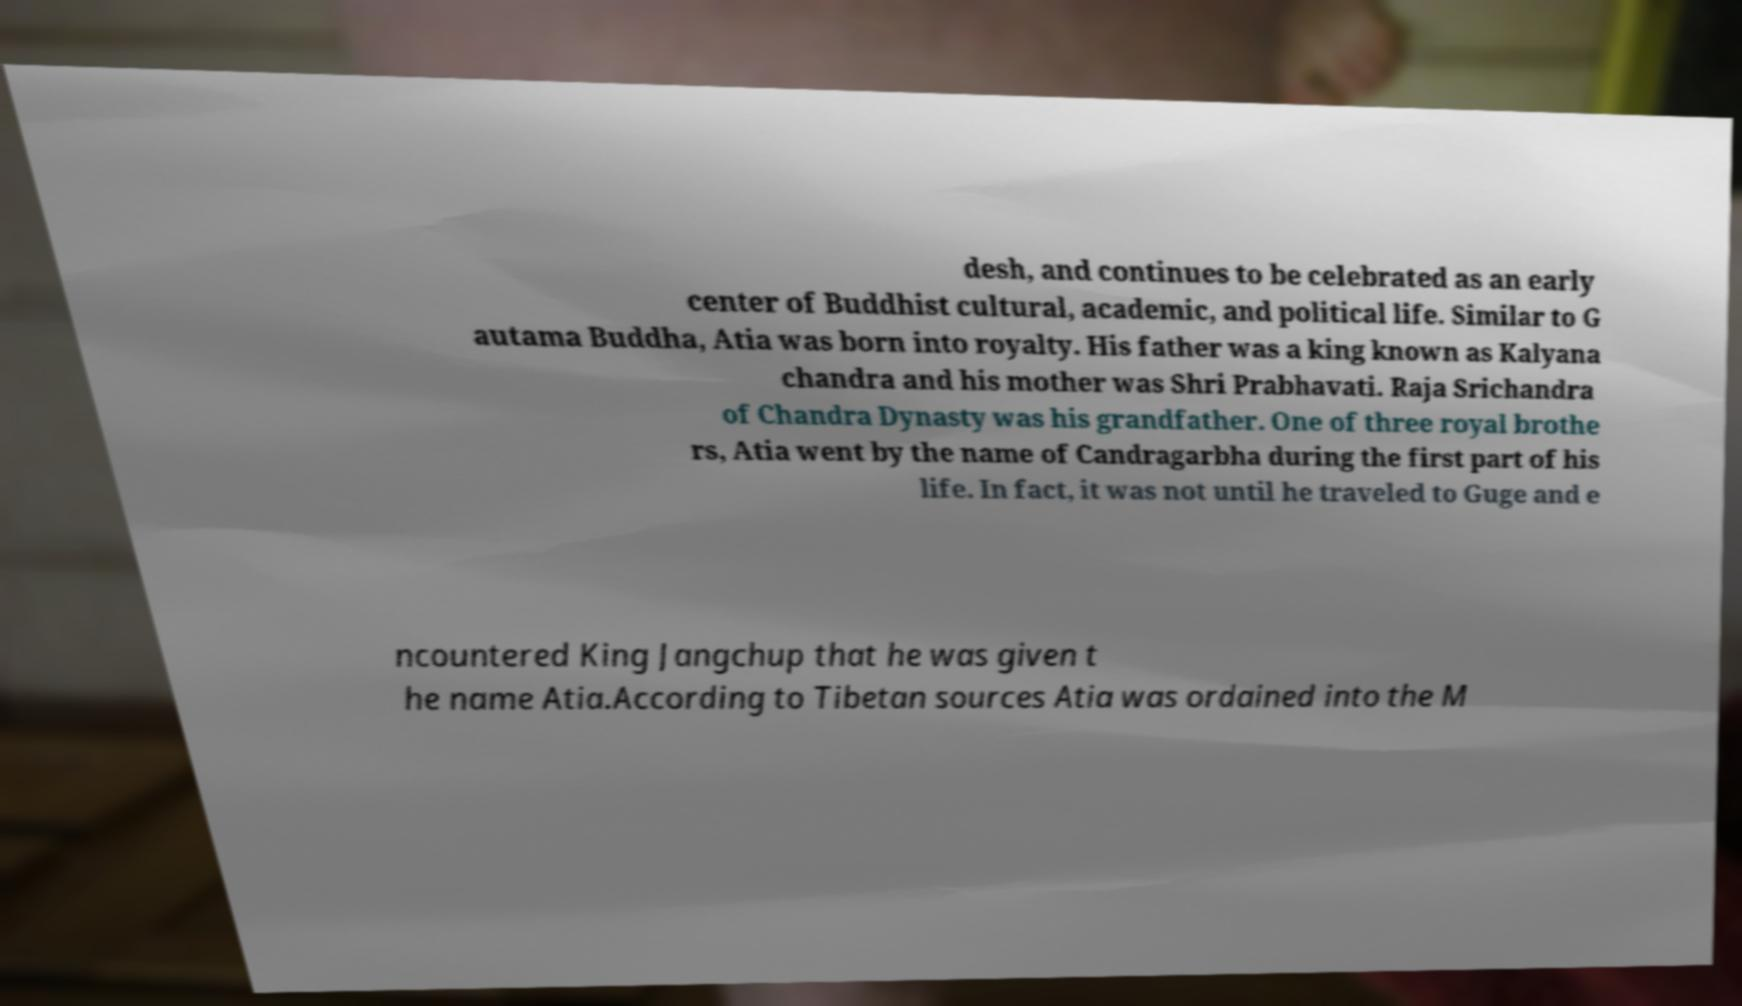Can you accurately transcribe the text from the provided image for me? desh, and continues to be celebrated as an early center of Buddhist cultural, academic, and political life. Similar to G autama Buddha, Atia was born into royalty. His father was a king known as Kalyana chandra and his mother was Shri Prabhavati. Raja Srichandra of Chandra Dynasty was his grandfather. One of three royal brothe rs, Atia went by the name of Candragarbha during the first part of his life. In fact, it was not until he traveled to Guge and e ncountered King Jangchup that he was given t he name Atia.According to Tibetan sources Atia was ordained into the M 